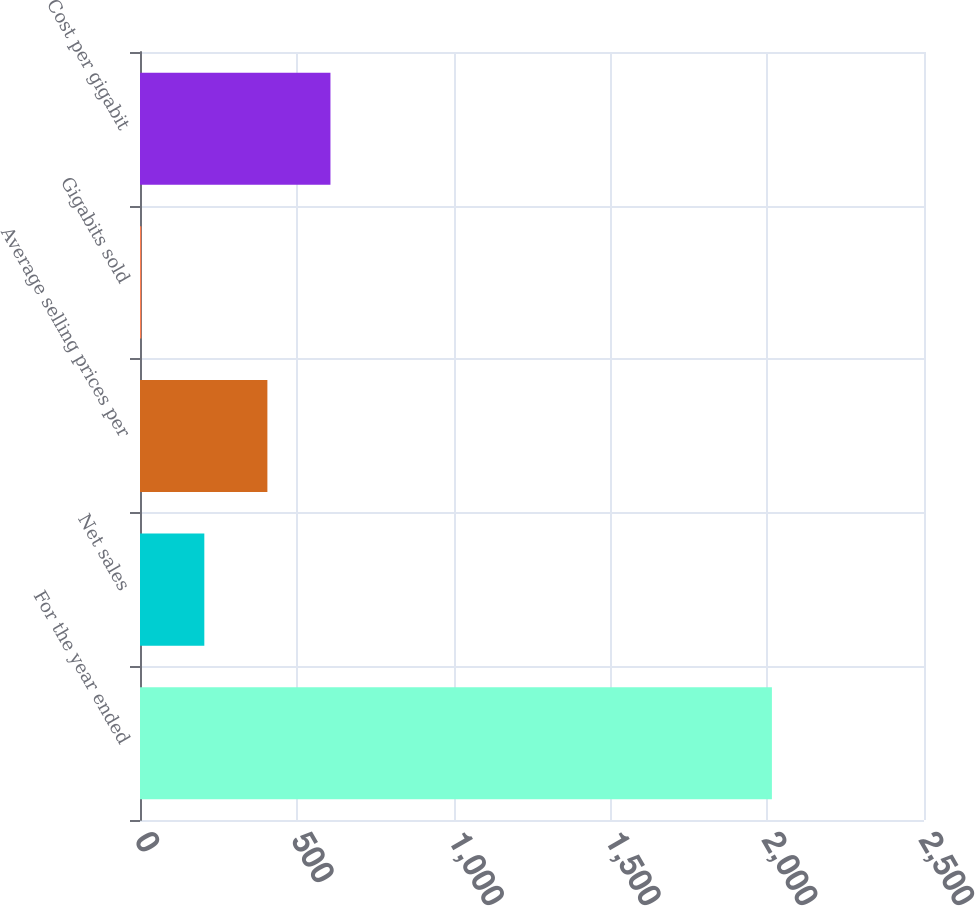<chart> <loc_0><loc_0><loc_500><loc_500><bar_chart><fcel>For the year ended<fcel>Net sales<fcel>Average selling prices per<fcel>Gigabits sold<fcel>Cost per gigabit<nl><fcel>2015<fcel>205.1<fcel>406.2<fcel>4<fcel>607.3<nl></chart> 